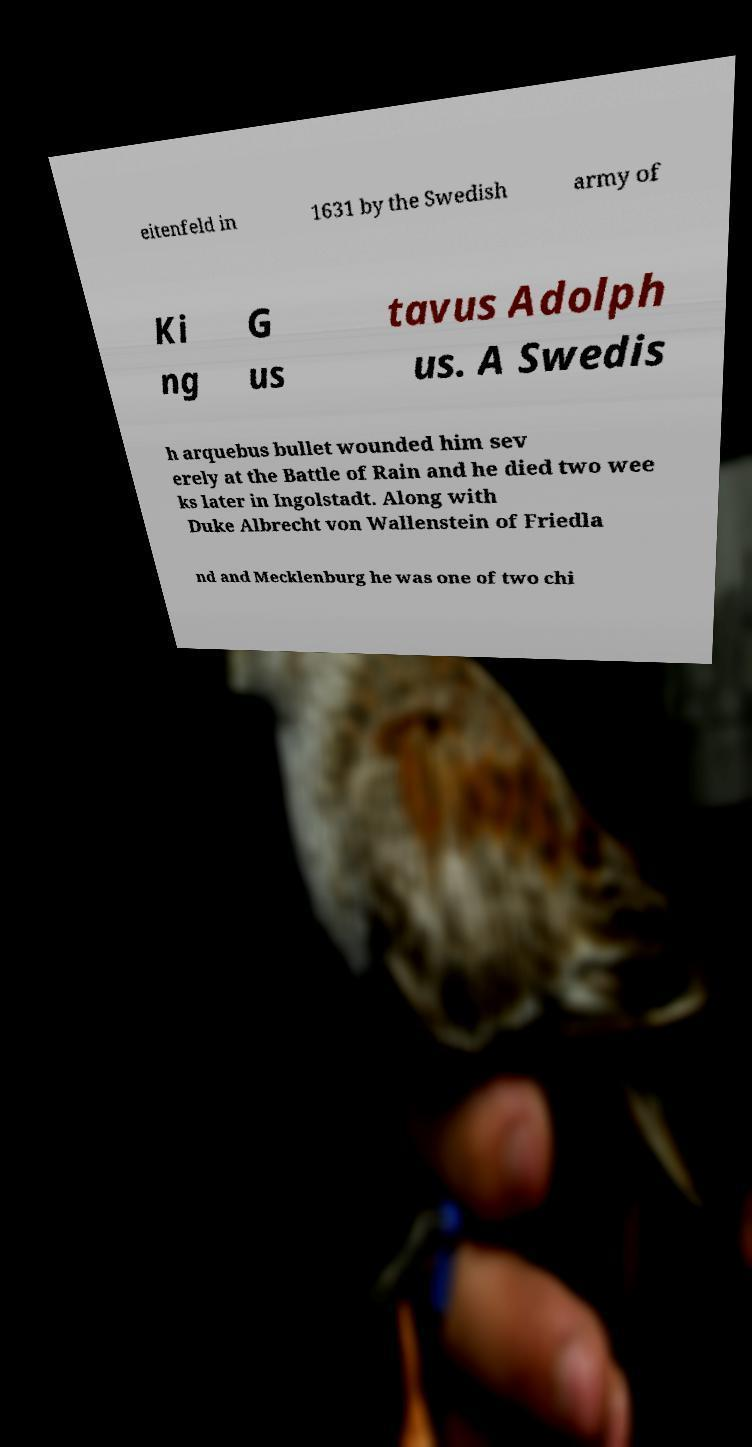Please read and relay the text visible in this image. What does it say? eitenfeld in 1631 by the Swedish army of Ki ng G us tavus Adolph us. A Swedis h arquebus bullet wounded him sev erely at the Battle of Rain and he died two wee ks later in Ingolstadt. Along with Duke Albrecht von Wallenstein of Friedla nd and Mecklenburg he was one of two chi 